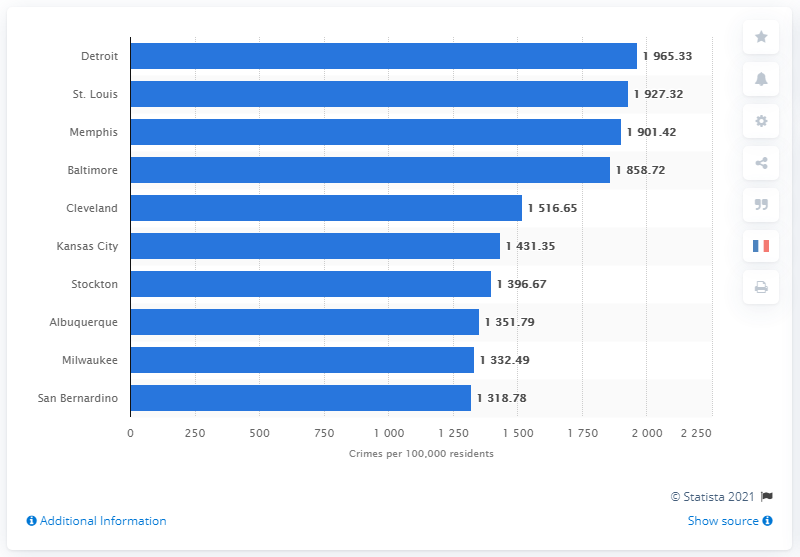Point out several critical features in this image. According to data from 2019, Detroit was the most dangerous city in the United States. In 2019, the violent crime rate in Detroit was approximately 1965.33 incidents per 100,000 residents. 